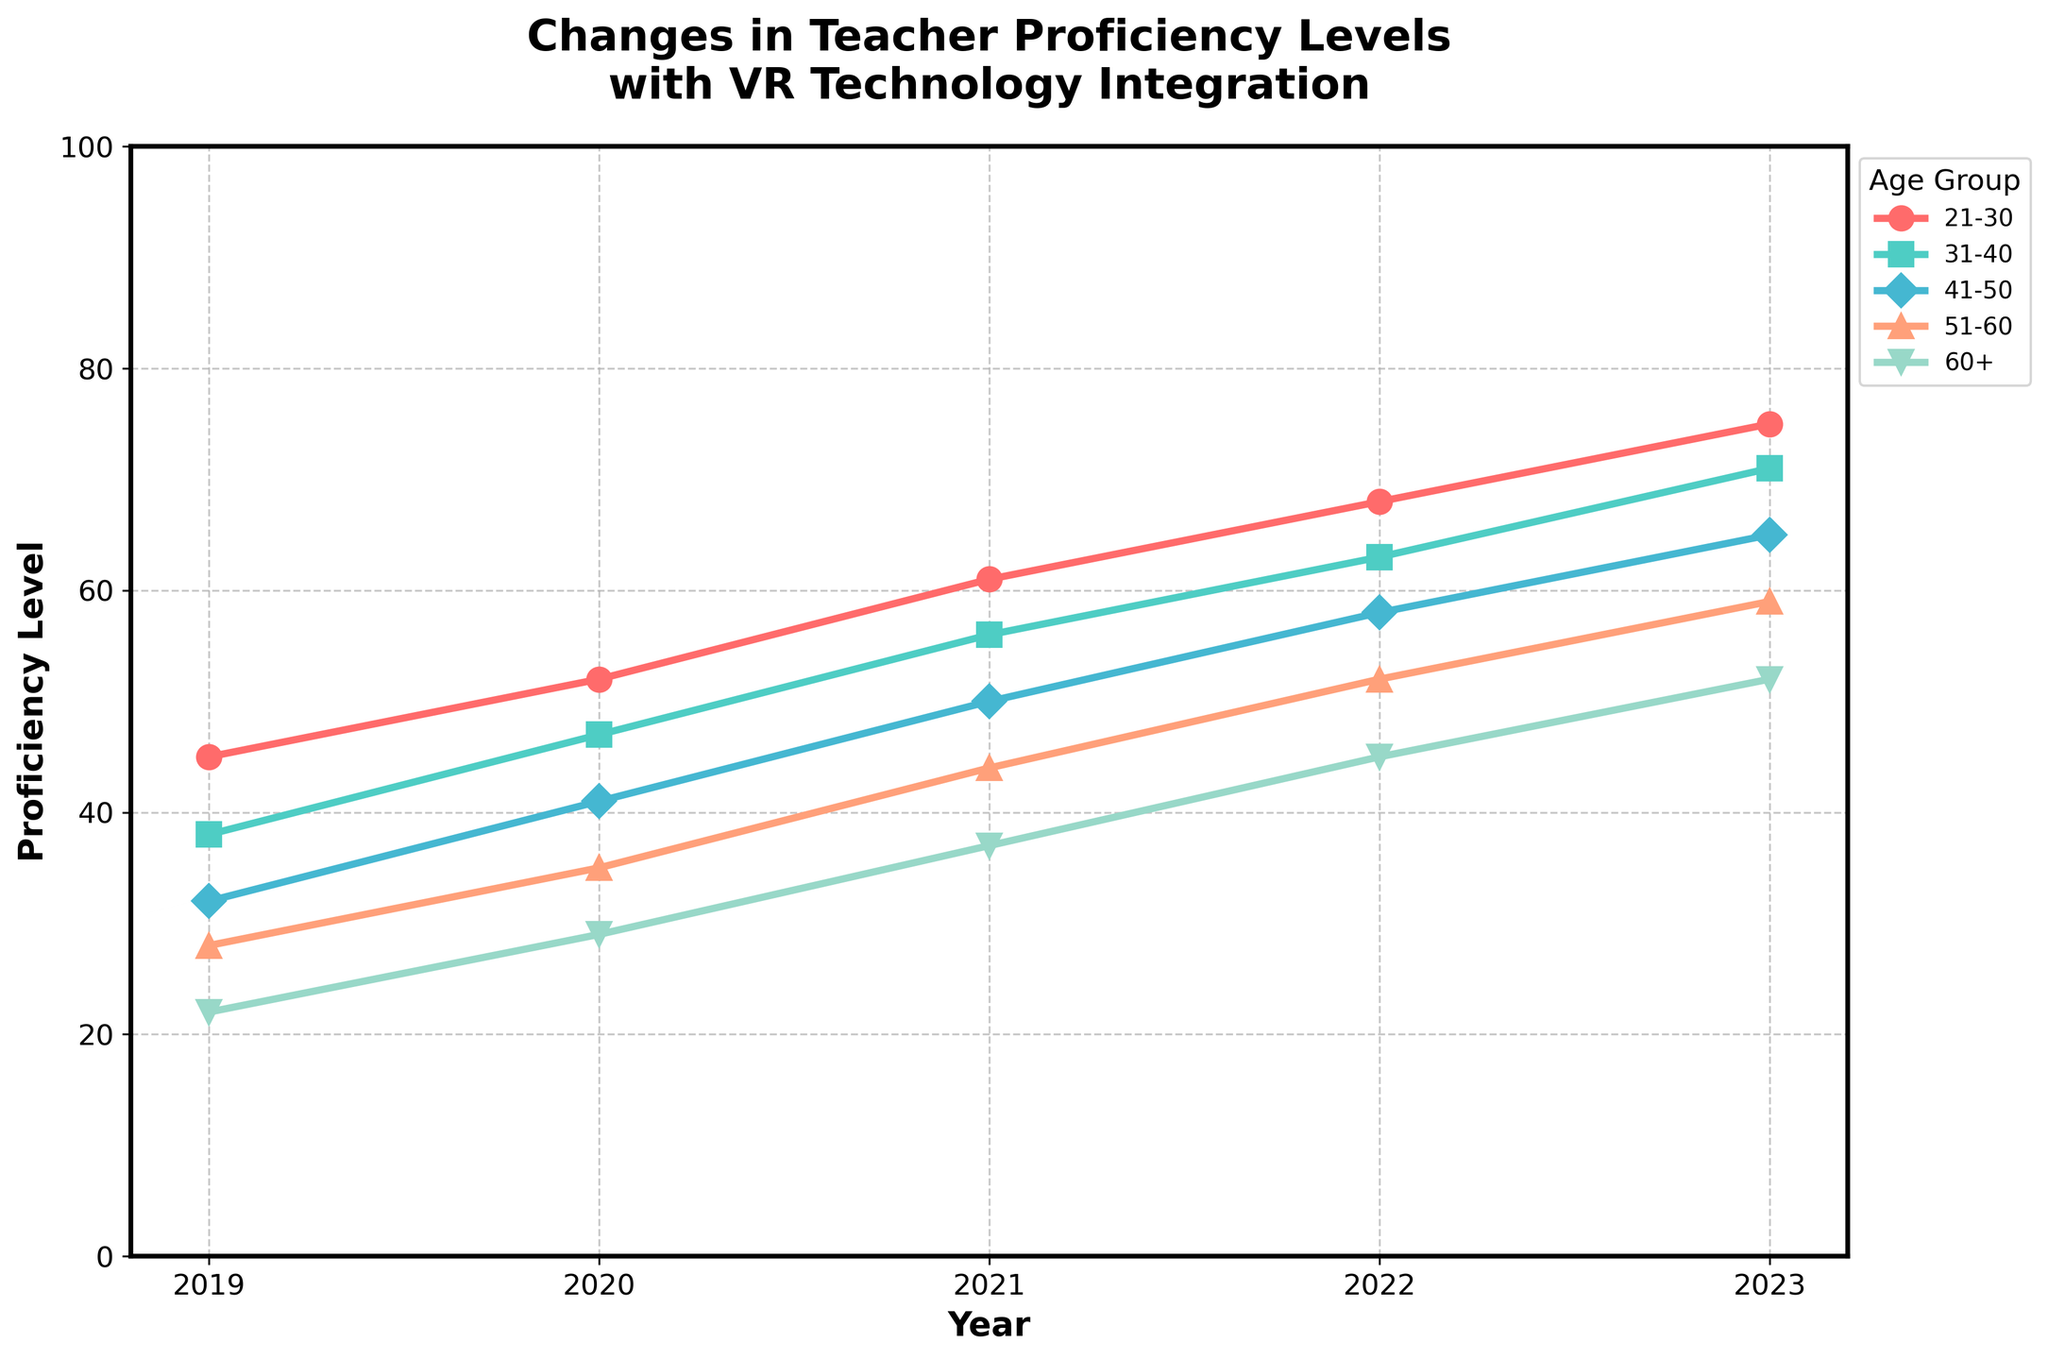What's the average increase in proficiency for the 21-30 age group from 2019 to 2023? Calculate the difference in proficiency levels between 2023 and 2019 for the 21-30 age group: 75 - 45 = 30. Then, divide this difference by the number of years (2023 - 2019 = 4) to find the average annual increase: 30 / 4 = 7.5
Answer: 7.5 Which age group saw the largest overall increase in proficiency from 2019 to 2023? Calculate the difference in proficiency levels between 2023 and 2019 for each age group: 21-30: 75-45=30, 31-40: 71-38=33, 41-50: 65-32=33, 51-60: 59-28=31, 60+: 52-22=30. The 31-40 and 41-50 age groups both saw an increase of 33 points, which is the largest.
Answer: 31-40 and 41-50 In which year did all age groups see an increase compared to the previous year? Compare each year's proficiency levels with the previous year's for all age groups. Each year from 2019 to 2023 shows an increase in proficiency for all age groups compared to the year before.
Answer: Every year Which age group had the lowest proficiency level in 2020? Compare proficiency levels for all age groups in 2020. The 60+ age group had the lowest proficiency level at 29.
Answer: 60+ How much did the proficiency of the 60+ age group increase from 2020 to 2021? Calculate the difference in proficiency levels for the 60+ age group between 2021 and 2020: 37 - 29 = 8.
Answer: 8 Which age group had similar proficiency levels in 2019 and 2020? Compare the proficiency levels of each age group between 2019 and 2020. The 51-60 age group increased from 28 to 35, and the 41-50 age group increased from 32 to 41, both showing an increase of 7 points, indicating similar growth trends.
Answer: 51-60 and 41-50 What is the trend for the 31-40 age group's proficiency levels over the years? Observe the changes in the proficiency levels of the 31-40 age group from 2019 to 2023: 38 (2019), 47 (2020), 56 (2021), 63 (2022), 71 (2023). The proficiency level consistently increases each year.
Answer: Consistently increasing Which age group shows the most pronounced upward trend visually? The 21-30 age group shows the most pronounced upward trend visually with the steepest increase in the gradient of its line.
Answer: 21-30 Compare the proficiency growth between the 21-30 and 60+ age groups over the five years. Calculate the difference from 2019 to 2023 for both age groups: 21-30 increased from 45 to 75 (30 points), and 60+ increased from 22 to 52 (30 points). Despite equal numerical increases, the visual trend shows the 21-30 group has a steeper and more consistent upward trajectory.
Answer: 21-30 shows steeper growth How did the proficiency of the 41-50 age group change from 2022 to 2023? Calculate the difference in proficiency levels for the 41-50 age group between 2023 and 2022: 65 - 58 = 7.
Answer: 7 